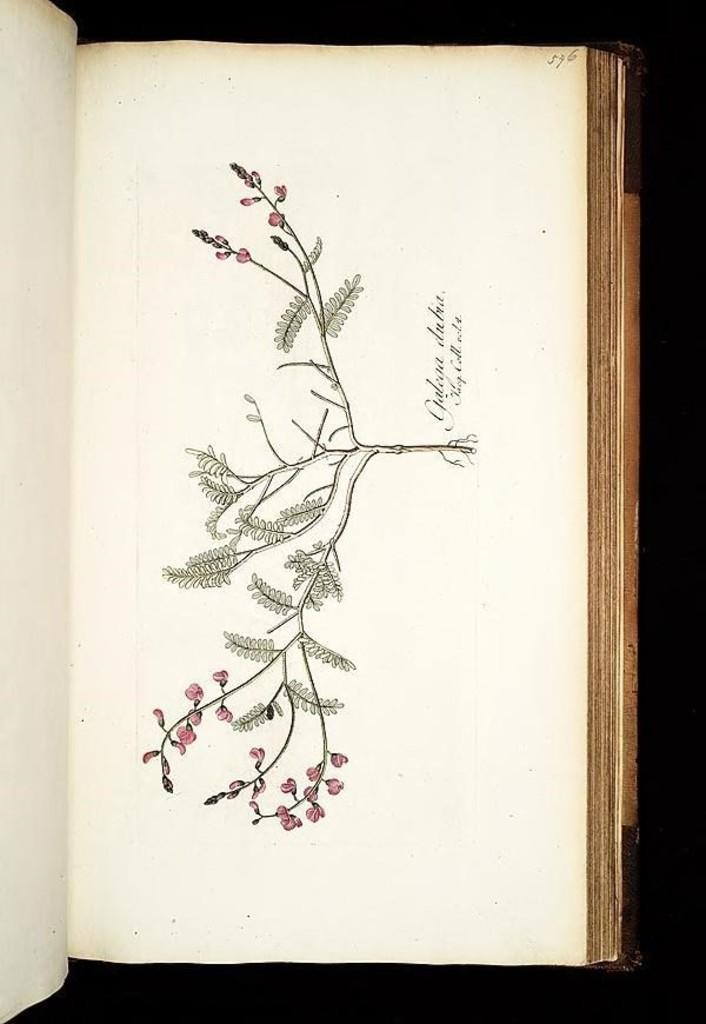What is the main subject of the image? The main subject of the image is a book. What can be found within the book? There is a painting of a plant in the book. What is special about the plant in the painting? The plant in the painting has pink flowers. What else is present in the book besides the painting? There is text in the book. How many birds are perched on the plant in the painting? There are no birds present in the painting; it only features a plant with pink flowers. 